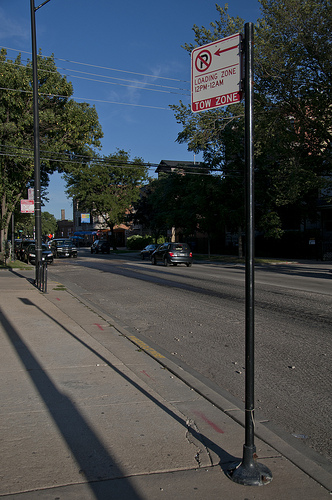Is this street typically busy, and can you infer anything about the neighborhood from the image? The street doesn't appear very busy at the moment, suggesting the photo might have been taken during a non-peak hour. The neighborhood looks residential with trees lining the sidewalks, indicating a tranquil, urban atmosphere. What can you tell about the weather on this day? The sky is clear and blue without any visible clouds suggesting that the weather is fair and it's likely a sunny day. 